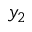<formula> <loc_0><loc_0><loc_500><loc_500>y _ { 2 }</formula> 